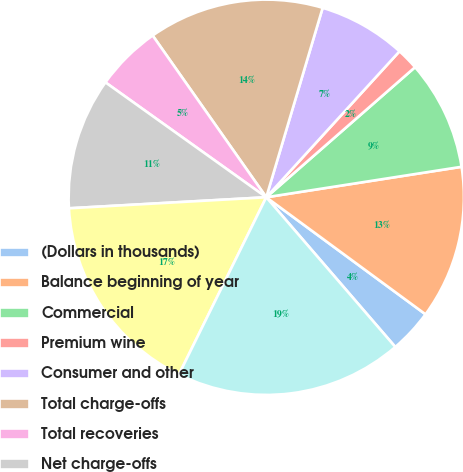Convert chart to OTSL. <chart><loc_0><loc_0><loc_500><loc_500><pie_chart><fcel>(Dollars in thousands)<fcel>Balance beginning of year<fcel>Commercial<fcel>Premium wine<fcel>Consumer and other<fcel>Total charge-offs<fcel>Total recoveries<fcel>Net charge-offs<fcel>Provision for loan losses<fcel>Balance end of year<nl><fcel>3.59%<fcel>12.55%<fcel>8.97%<fcel>1.79%<fcel>7.17%<fcel>14.35%<fcel>5.38%<fcel>10.76%<fcel>16.82%<fcel>18.61%<nl></chart> 